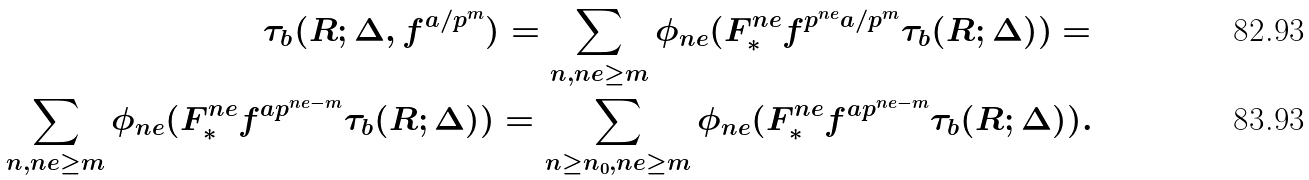Convert formula to latex. <formula><loc_0><loc_0><loc_500><loc_500>\tau _ { b } ( R ; \Delta , f ^ { a / p ^ { m } } ) = \sum _ { n , n e \geq m } \phi _ { n e } ( F ^ { n e } _ { * } f ^ { p ^ { n e } a / p ^ { m } } \tau _ { b } ( R ; \Delta ) ) = \\ \sum _ { n , n e \geq m } \phi _ { n e } ( F ^ { n e } _ { * } f ^ { a p ^ { n e - m } } \tau _ { b } ( R ; \Delta ) ) = \sum _ { n \geq n _ { 0 } , n e \geq m } \phi _ { n e } ( F ^ { n e } _ { * } f ^ { a p ^ { n e - m } } \tau _ { b } ( R ; \Delta ) ) .</formula> 